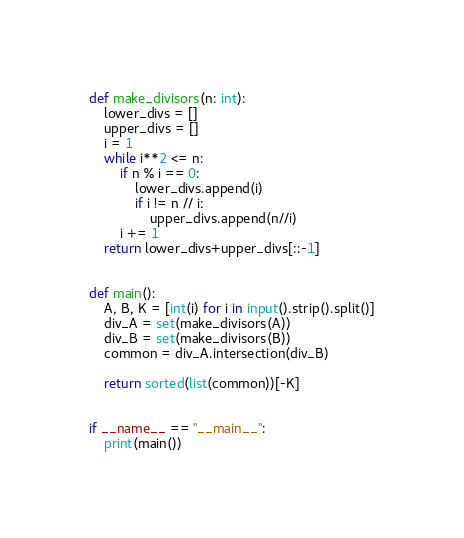<code> <loc_0><loc_0><loc_500><loc_500><_Python_>def make_divisors(n: int):
    lower_divs = []
    upper_divs = []
    i = 1
    while i**2 <= n:
        if n % i == 0:
            lower_divs.append(i)
            if i != n // i:
                upper_divs.append(n//i)
        i += 1
    return lower_divs+upper_divs[::-1]


def main():
    A, B, K = [int(i) for i in input().strip().split()]
    div_A = set(make_divisors(A))
    div_B = set(make_divisors(B))
    common = div_A.intersection(div_B)

    return sorted(list(common))[-K]


if __name__ == "__main__":
    print(main())
</code> 